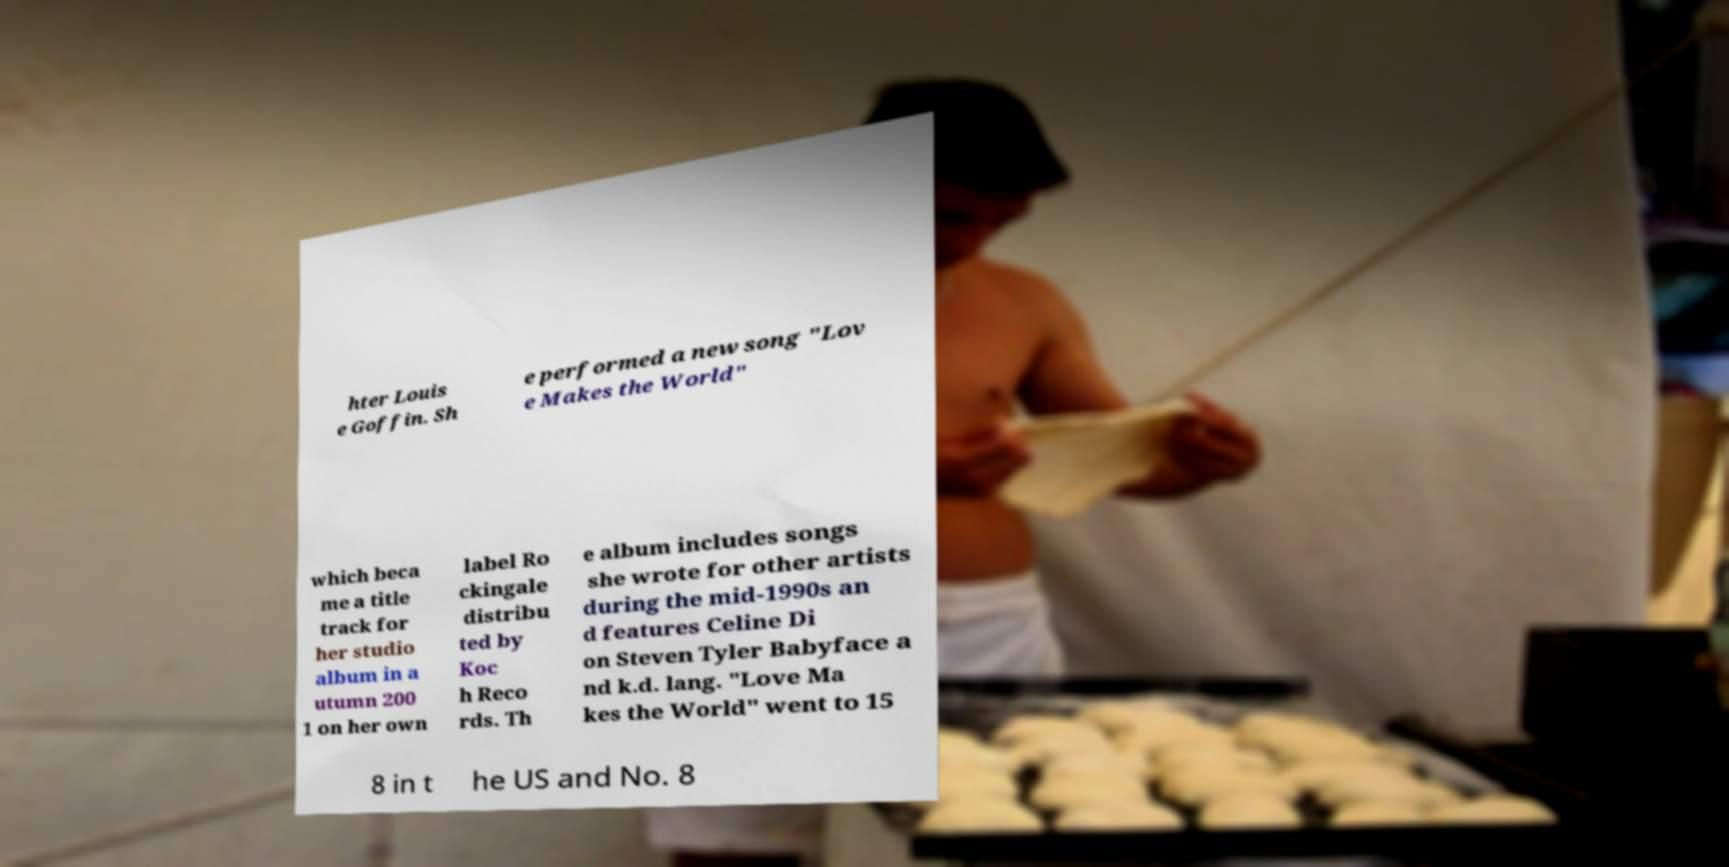Please read and relay the text visible in this image. What does it say? hter Louis e Goffin. Sh e performed a new song "Lov e Makes the World" which beca me a title track for her studio album in a utumn 200 1 on her own label Ro ckingale distribu ted by Koc h Reco rds. Th e album includes songs she wrote for other artists during the mid-1990s an d features Celine Di on Steven Tyler Babyface a nd k.d. lang. "Love Ma kes the World" went to 15 8 in t he US and No. 8 